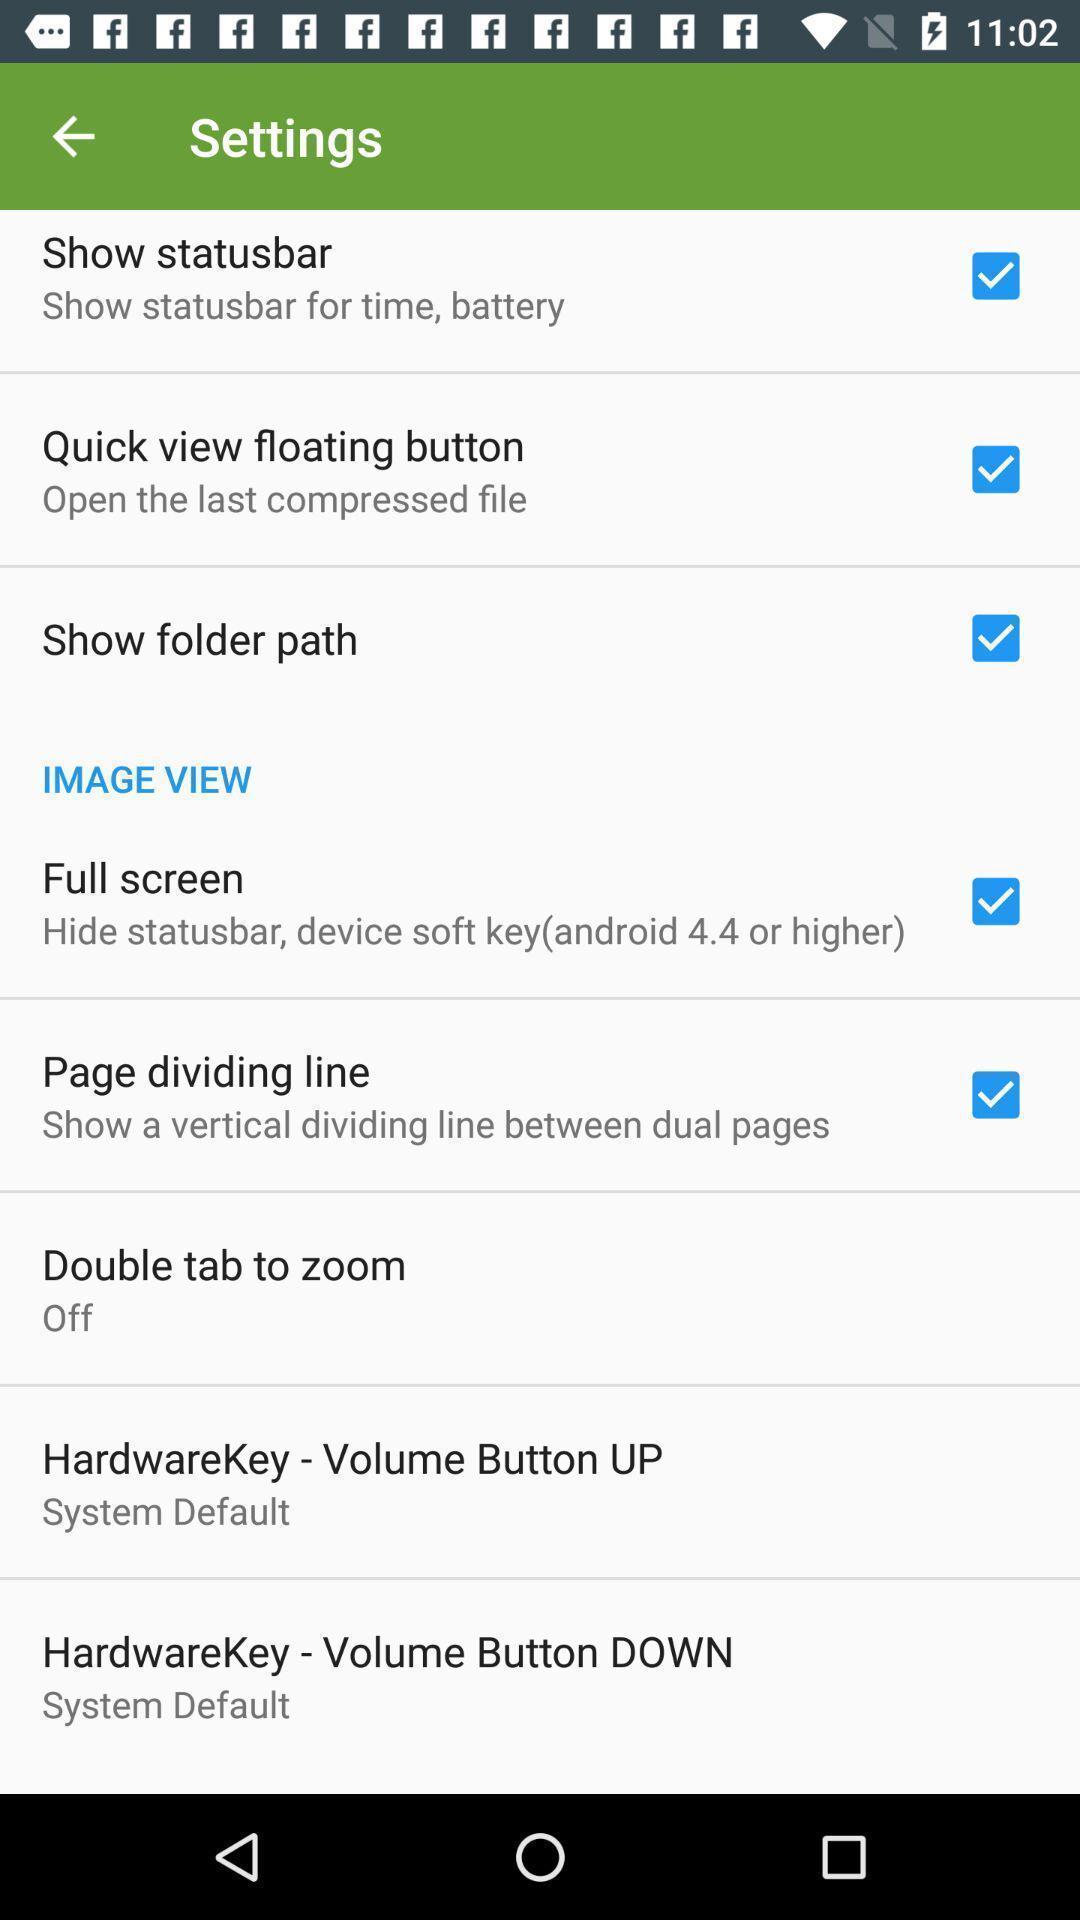Describe the visual elements of this screenshot. Settings page with various other options. 